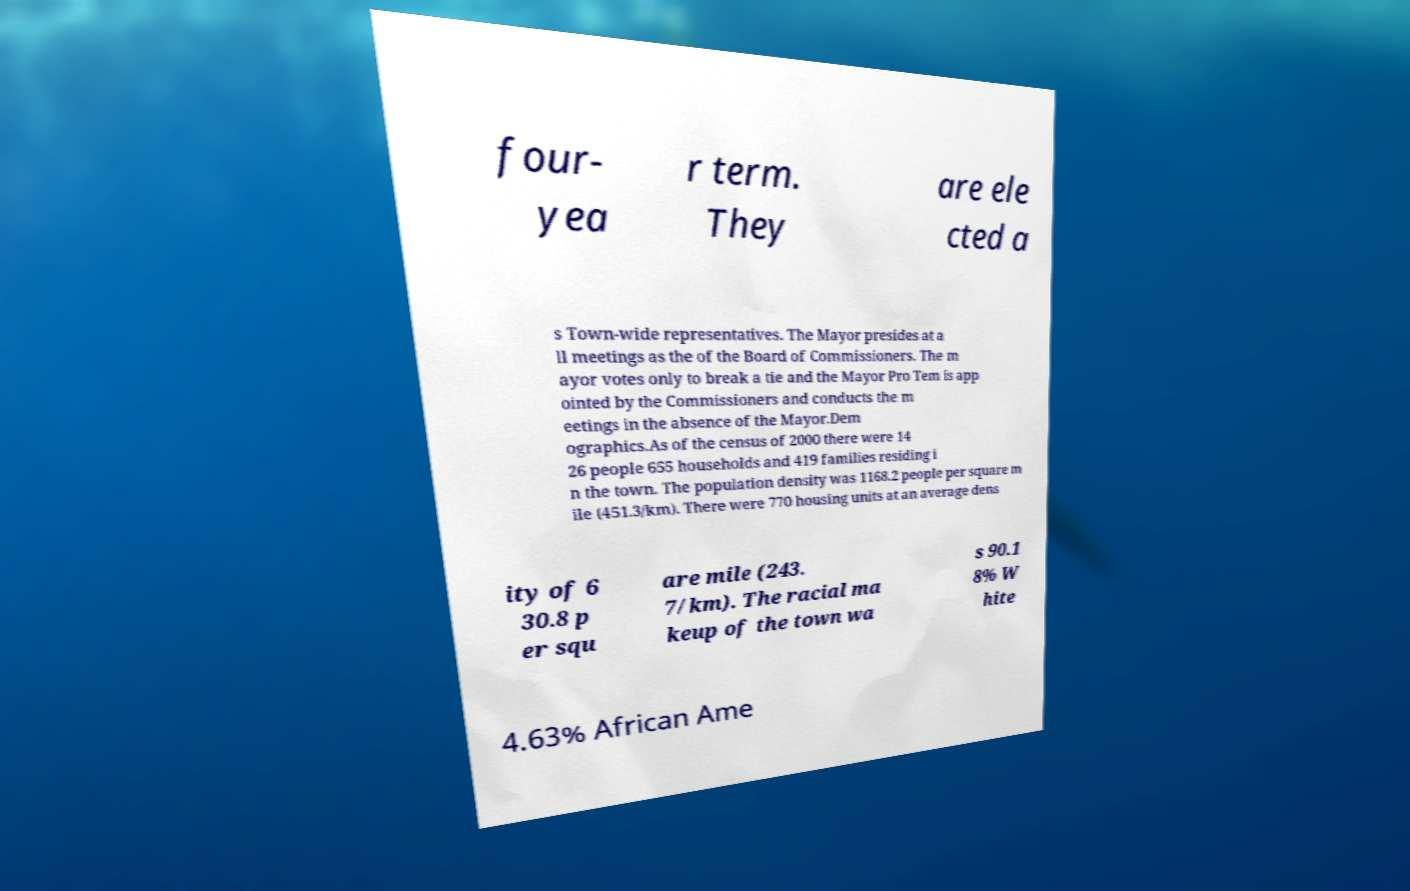Could you assist in decoding the text presented in this image and type it out clearly? four- yea r term. They are ele cted a s Town-wide representatives. The Mayor presides at a ll meetings as the of the Board of Commissioners. The m ayor votes only to break a tie and the Mayor Pro Tem is app ointed by the Commissioners and conducts the m eetings in the absence of the Mayor.Dem ographics.As of the census of 2000 there were 14 26 people 655 households and 419 families residing i n the town. The population density was 1168.2 people per square m ile (451.3/km). There were 770 housing units at an average dens ity of 6 30.8 p er squ are mile (243. 7/km). The racial ma keup of the town wa s 90.1 8% W hite 4.63% African Ame 